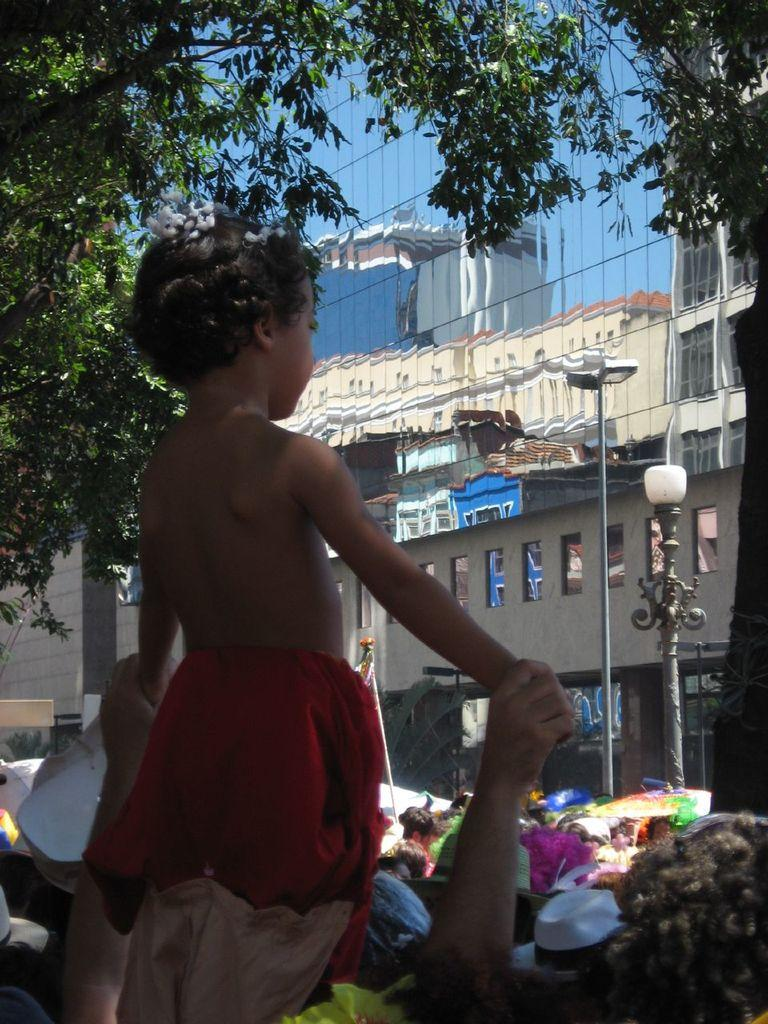Who is on the left side of the image? There is a girl and a person on the left side of the image. What can be seen in the middle of the image? There are many people in the middle of the image. What type of structures are present in the image? There are buildings in the image. What objects provide illumination in the image? There are street lights in the image. What material is present in the image? There is glass in the image. What type of vegetation is present in the image? There are trees in the image. What type of rake is being used to clean the glass in the image? There is no rake present in the image, and the glass is not being cleaned. 